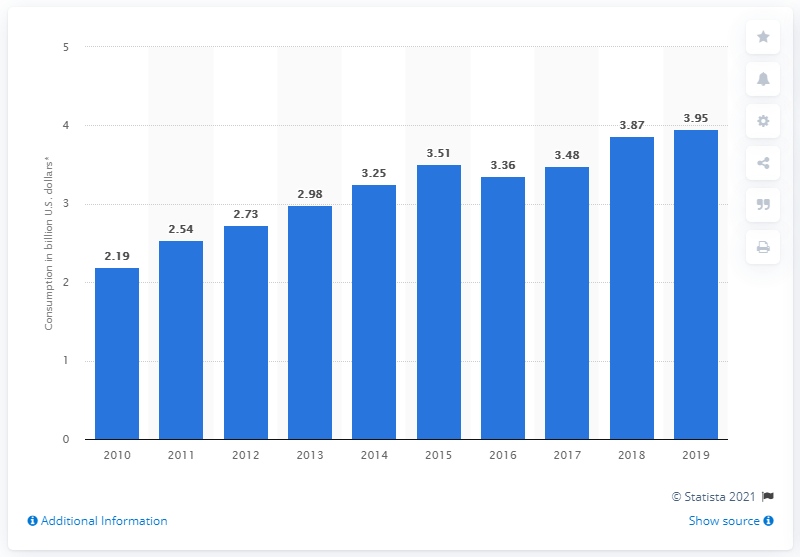List a handful of essential elements in this visual. In 2010, Ecuador spent approximately 2.19 billion US dollars on travel and tourism. 